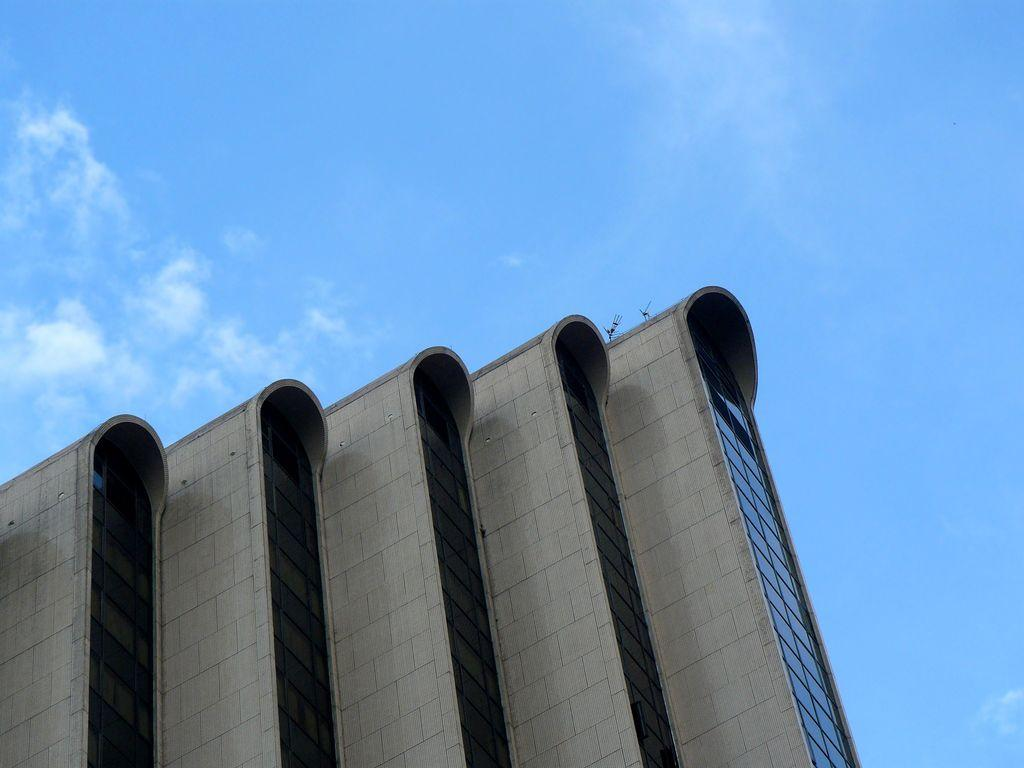What type of structure is located at the bottom of the image? There is a building at the bottom of the image. What feature can be observed on the building? The building has glass windows. What is visible at the top of the image? The sky is visible at the top of the image. What can be seen in the sky? Clouds are present in the sky. What type of flesh can be seen growing on the building in the image? There is no flesh present on the building in the image; it is a structure made of materials like concrete, glass, or steel. 